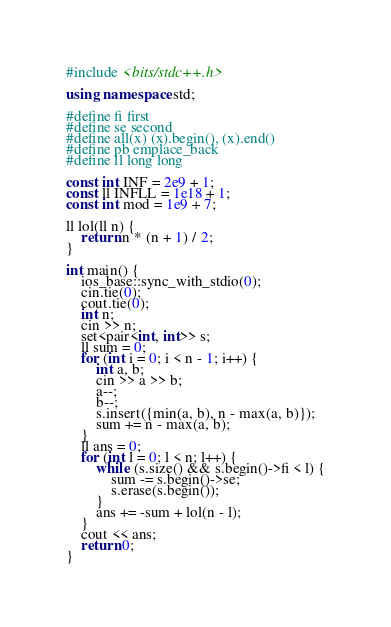<code> <loc_0><loc_0><loc_500><loc_500><_C++_>#include <bits/stdc++.h>

using namespace std;

#define fi first
#define se second
#define all(x) (x).begin(), (x).end()
#define pb emplace_back
#define ll long long

const int INF = 2e9 + 1;
const ll INFLL = 1e18 + 1;
const int mod = 1e9 + 7;

ll lol(ll n) {
    return n * (n + 1) / 2;
}

int main() {
    ios_base::sync_with_stdio(0);
    cin.tie(0);
    cout.tie(0);
    int n;
    cin >> n;
    set<pair<int, int>> s;
    ll sum = 0;
    for (int i = 0; i < n - 1; i++) {
        int a, b;
        cin >> a >> b;
        a--;
        b--;
        s.insert({min(a, b), n - max(a, b)});
        sum += n - max(a, b);
    }
    ll ans = 0;
    for (int l = 0; l < n; l++) {
        while (s.size() && s.begin()->fi < l) {
            sum -= s.begin()->se;
            s.erase(s.begin());
        }
        ans += -sum + lol(n - l);
    }
    cout << ans;
    return 0;
}
</code> 